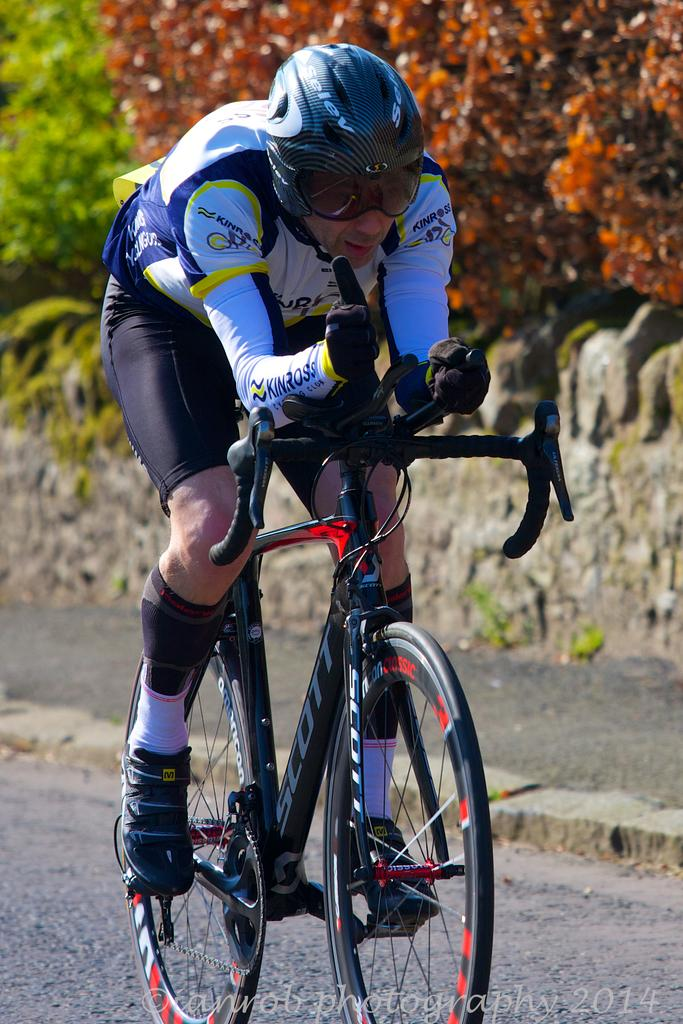What is the main activity of the person in the image? The person is cycling in the image. Where is the cyclist located? The person is on the road. What can be seen behind the cyclist? There is a wall behind the cyclist. What type of vegetation is present in the image? There are trees in the image. What is written or displayed at the bottom of the image? There is some text at the bottom of the image. What type of owl can be seen perched on the cyclist's shoulder in the image? There is no owl present in the image; the person is cycling alone. 